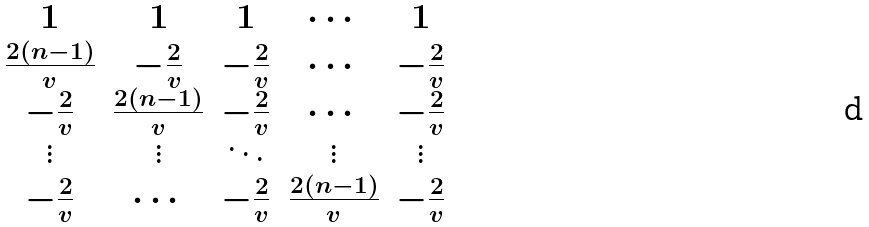<formula> <loc_0><loc_0><loc_500><loc_500>\begin{matrix} 1 & 1 & 1 & \cdots & 1 \\ \frac { 2 ( n - 1 ) } { v } & - \frac { 2 } { v } & - \frac { 2 } { v } & \cdots & - \frac { 2 } { v } \\ - \frac { 2 } { v } & \frac { 2 ( n - 1 ) } { v } & - \frac { 2 } { v } & \cdots & - \frac { 2 } { v } \\ \vdots & \vdots & \ddots & \vdots & \vdots \\ - \frac { 2 } { v } & \cdots & - \frac { 2 } { v } & \frac { 2 ( n - 1 ) } { v } & - \frac { 2 } { v } \end{matrix}</formula> 